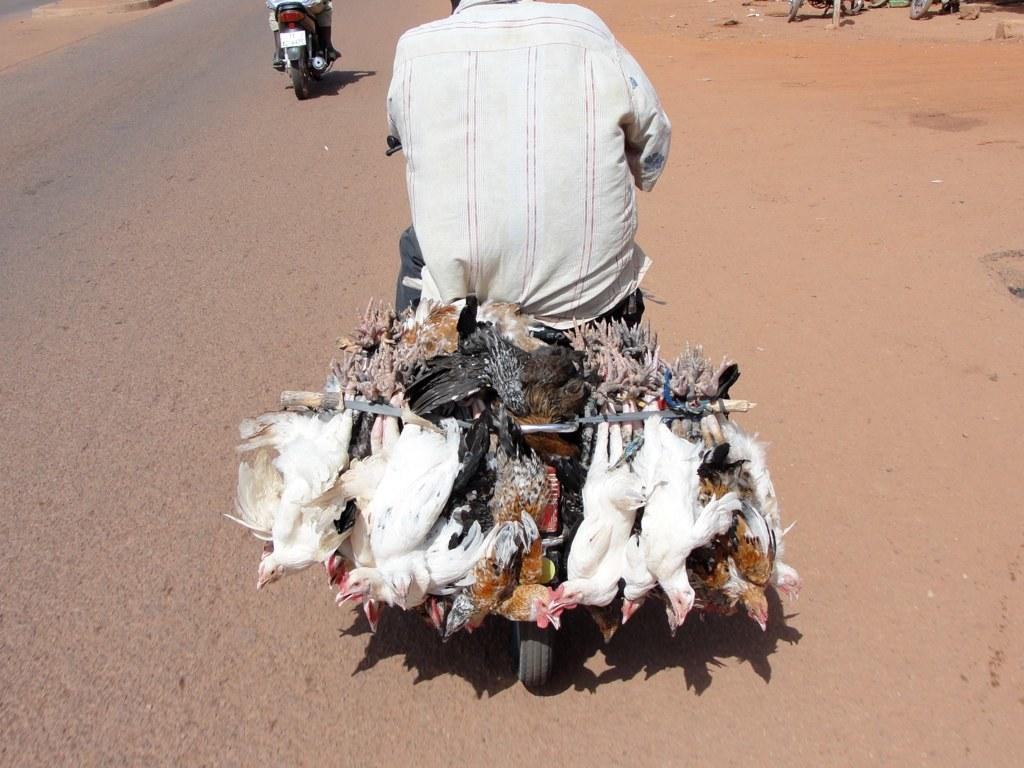What are the two people in the image doing? The two people in the image are riding motorbikes. Where are the motorbikes located? The motorbikes are on a road. What unusual item can be seen hanging from one of the motorbikes? There are hens hanging from one of the motorbikes. What type of appliance is being used by the carpenter in the image? There is no carpenter or appliance present in the image. Can you tell me how many owls are sitting on the motorbikes in the image? There are no owls present in the image; only the two people and the hens can be seen. 